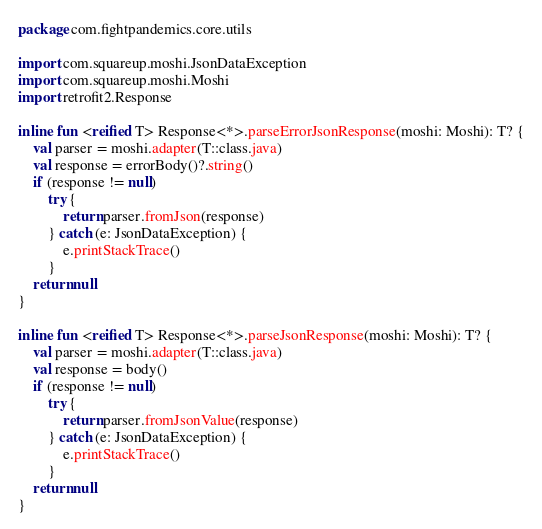Convert code to text. <code><loc_0><loc_0><loc_500><loc_500><_Kotlin_>package com.fightpandemics.core.utils

import com.squareup.moshi.JsonDataException
import com.squareup.moshi.Moshi
import retrofit2.Response

inline fun <reified T> Response<*>.parseErrorJsonResponse(moshi: Moshi): T? {
    val parser = moshi.adapter(T::class.java)
    val response = errorBody()?.string()
    if (response != null)
        try {
            return parser.fromJson(response)
        } catch (e: JsonDataException) {
            e.printStackTrace()
        }
    return null
}

inline fun <reified T> Response<*>.parseJsonResponse(moshi: Moshi): T? {
    val parser = moshi.adapter(T::class.java)
    val response = body()
    if (response != null)
        try {
            return parser.fromJsonValue(response)
        } catch (e: JsonDataException) {
            e.printStackTrace()
        }
    return null
}</code> 